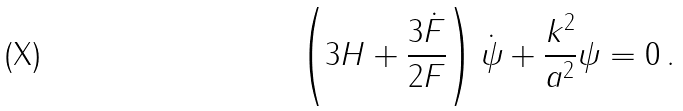<formula> <loc_0><loc_0><loc_500><loc_500>\left ( 3 H + \frac { 3 \dot { F } } { 2 F } \right ) \dot { \psi } + \frac { k ^ { 2 } } { a ^ { 2 } } \psi = 0 \, .</formula> 